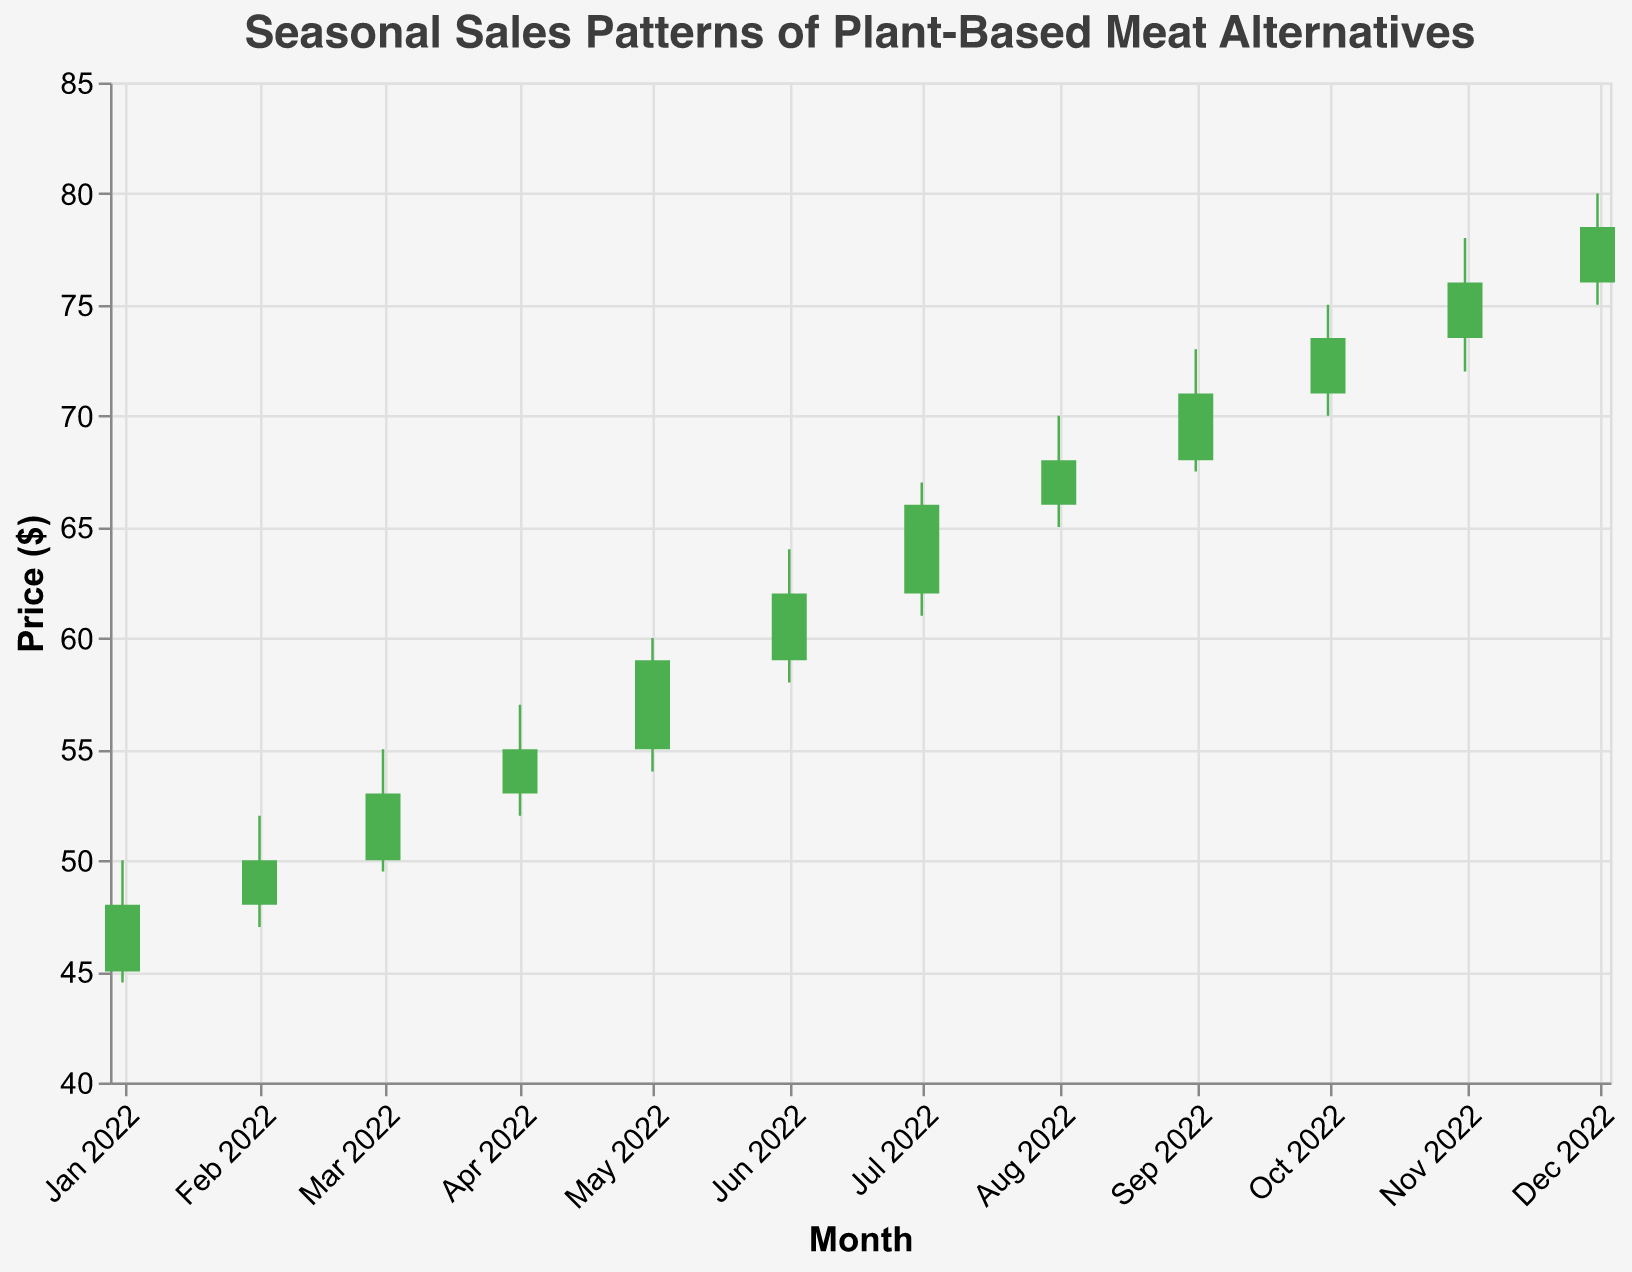What is the highest closing price in 2022? Scan through the Close prices and identify the highest value. The highest value observed is 78.50 in December 2022.
Answer: 78.50 In which month was the volume of sales the highest? Examine the Volume values for each month and identify the maximum. The volume is highest in July 2022 with 170,000.
Answer: July 2022 What was the difference between the opening price in January and December? Look at the opening prices for January (45.00) and December (76.00). Calculate the difference: 76.00 - 45.00 = 31.00.
Answer: 31.00 Which month had the lowest high price? Look at the High prices for each month and find the minimum value. The lowest High price is in January 2022 with a value of 50.00.
Answer: January 2022 How many months had a closing price higher than the opening price? Compare the Open and Close prices for each month. Count the months where Close > Open. This occurs in January, February, March, April, May, June, July, August, September, October, November, and December, totaling 12 months.
Answer: 12 months What is the average closing price over the year? Sum all the Close prices and divide by the number of months. The total sum of Close prices is 744.00. There are 12 months, so the average is 744.00 / 12 = 62.00.
Answer: 62.00 Which month saw the biggest increase in price from Open to Close? For each month, subtract the Open price from the Close price to find the difference. Identify the month with the largest difference. July shows the largest increase with Close - Open = 66.00 - 62.00 = 4.00.
Answer: July 2022 During which month was the price fluctuation (High - Low) the greatest? For each month, subtract the Low price from the High price to find the fluctuation. Identify the month with the largest fluctuation. The maximum fluctuation is in June with High - Low = 64.00 - 58.00 = 6.00.
Answer: June 2022 